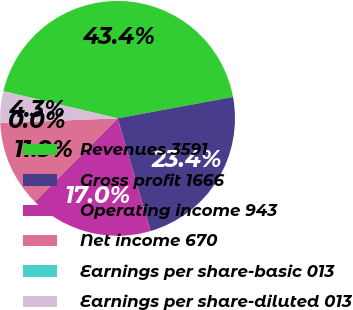Convert chart to OTSL. <chart><loc_0><loc_0><loc_500><loc_500><pie_chart><fcel>Revenues 3591<fcel>Gross profit 1666<fcel>Operating income 943<fcel>Net income 670<fcel>Earnings per share-basic 013<fcel>Earnings per share-diluted 013<nl><fcel>43.37%<fcel>23.39%<fcel>16.97%<fcel>11.94%<fcel>0.0%<fcel>4.34%<nl></chart> 